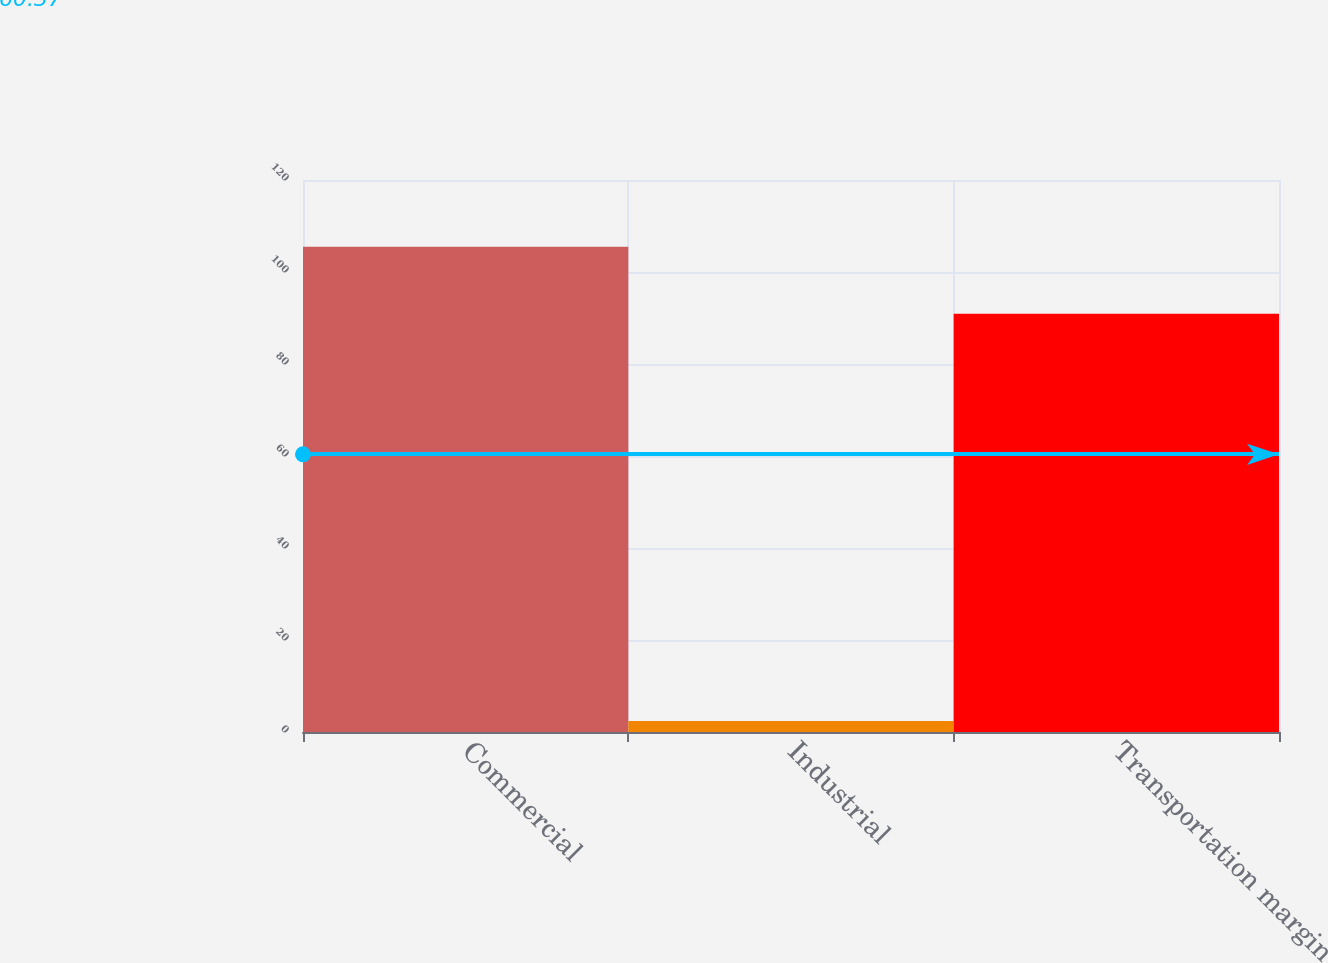<chart> <loc_0><loc_0><loc_500><loc_500><bar_chart><fcel>Commercial<fcel>Industrial<fcel>Transportation margin<nl><fcel>105.5<fcel>2.4<fcel>90.9<nl></chart> 